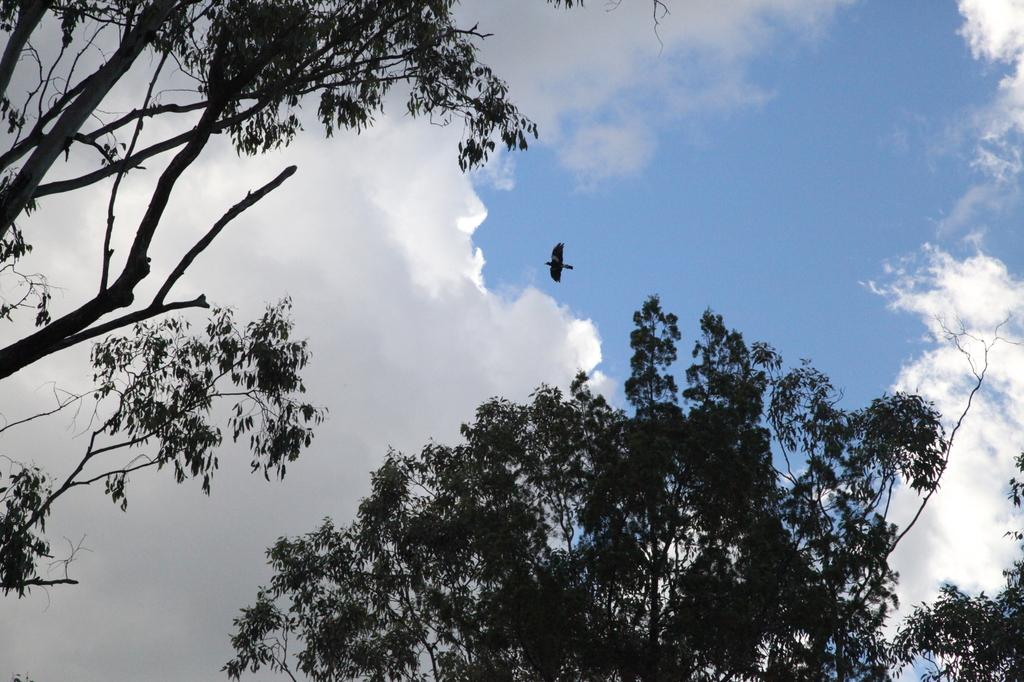What type of vegetation can be seen in the image? There are trees in the image. What animal is present in the image? There is a bird in the middle of the image. What can be seen in the sky in the image? There are clouds in the sky. What color are the bird's eyes in the image? The image does not show the bird's eyes, so we cannot determine their color. 